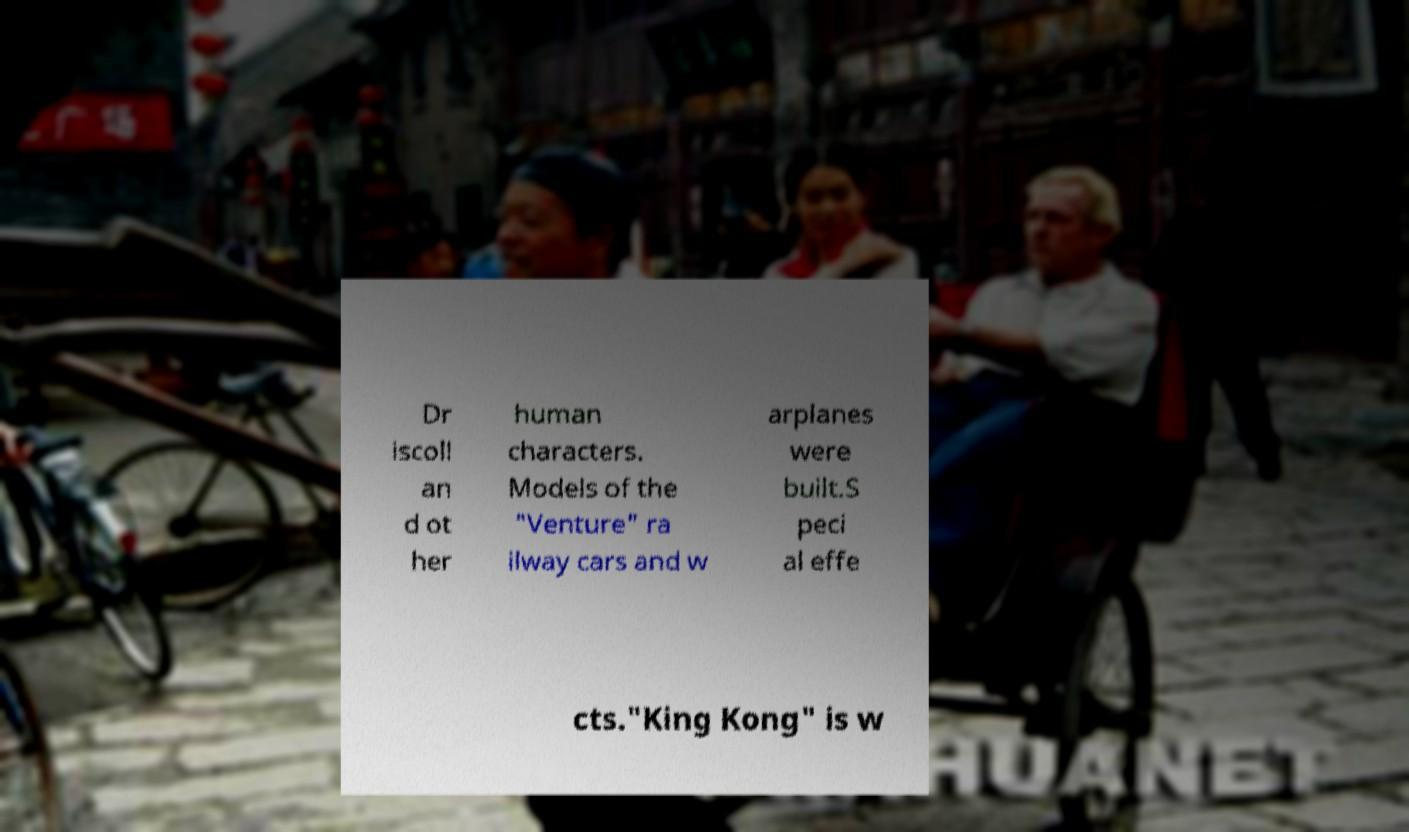There's text embedded in this image that I need extracted. Can you transcribe it verbatim? Dr iscoll an d ot her human characters. Models of the "Venture" ra ilway cars and w arplanes were built.S peci al effe cts."King Kong" is w 